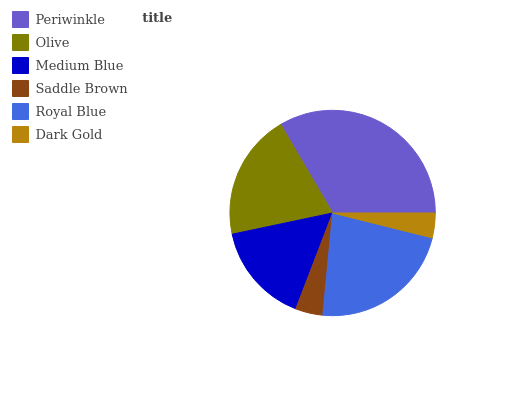Is Dark Gold the minimum?
Answer yes or no. Yes. Is Periwinkle the maximum?
Answer yes or no. Yes. Is Olive the minimum?
Answer yes or no. No. Is Olive the maximum?
Answer yes or no. No. Is Periwinkle greater than Olive?
Answer yes or no. Yes. Is Olive less than Periwinkle?
Answer yes or no. Yes. Is Olive greater than Periwinkle?
Answer yes or no. No. Is Periwinkle less than Olive?
Answer yes or no. No. Is Olive the high median?
Answer yes or no. Yes. Is Medium Blue the low median?
Answer yes or no. Yes. Is Dark Gold the high median?
Answer yes or no. No. Is Royal Blue the low median?
Answer yes or no. No. 